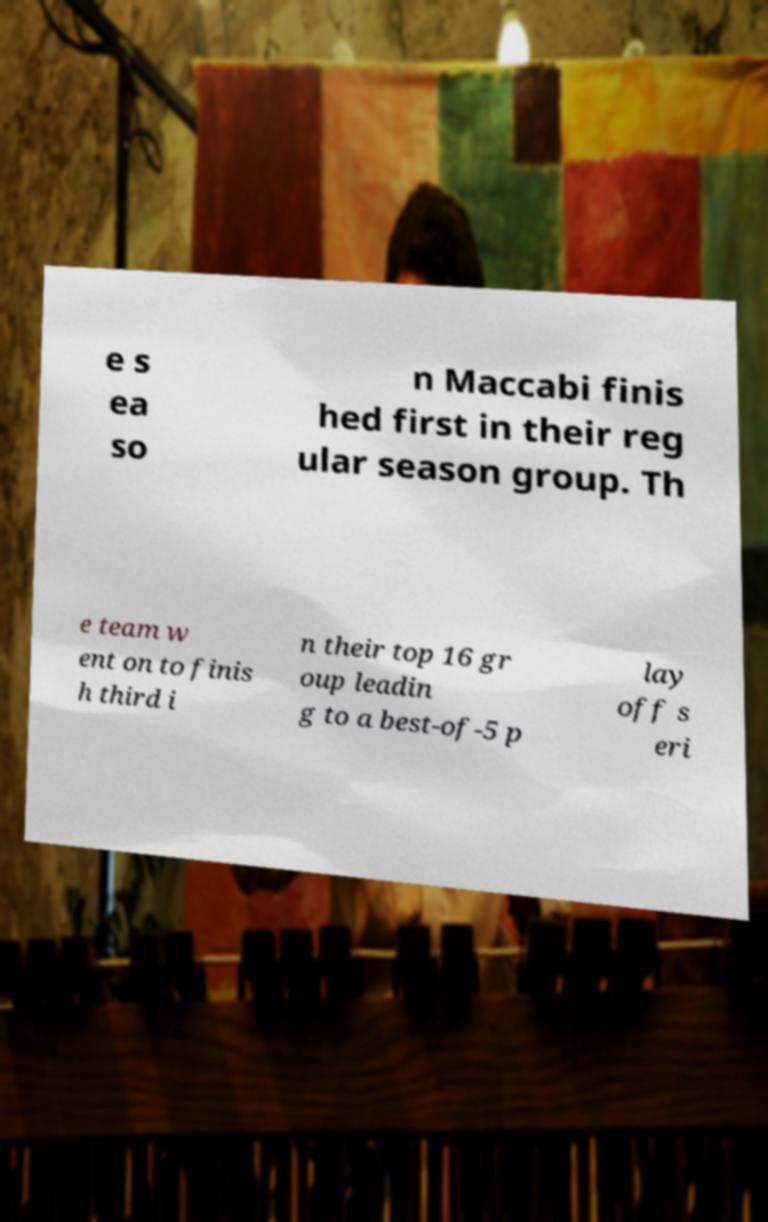Can you read and provide the text displayed in the image?This photo seems to have some interesting text. Can you extract and type it out for me? e s ea so n Maccabi finis hed first in their reg ular season group. Th e team w ent on to finis h third i n their top 16 gr oup leadin g to a best-of-5 p lay off s eri 